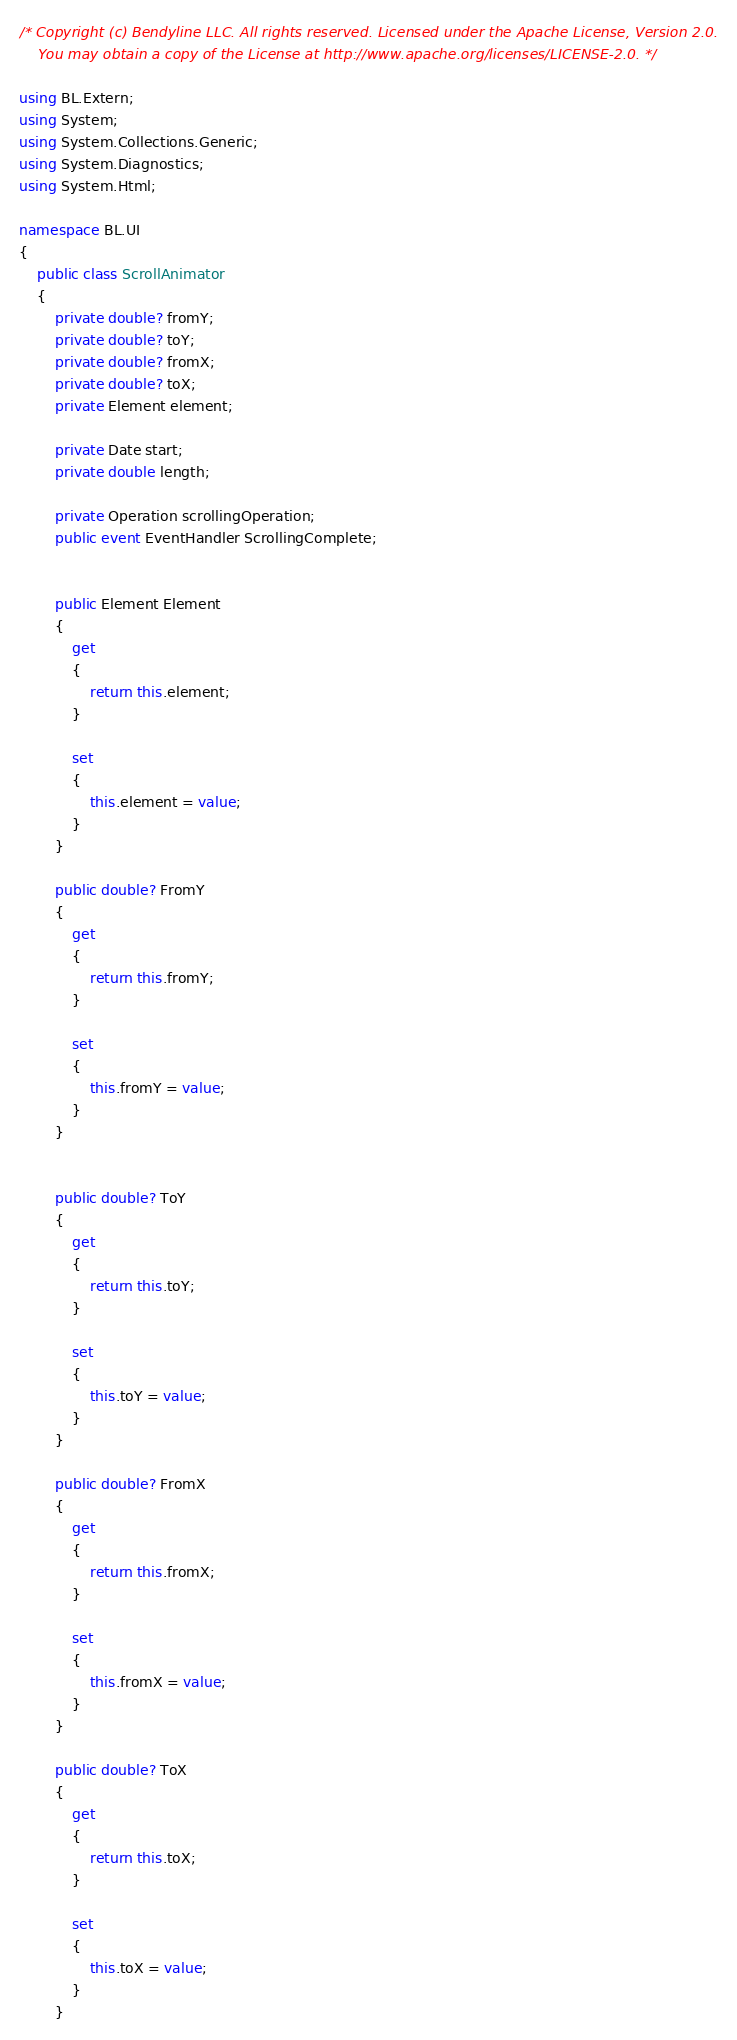<code> <loc_0><loc_0><loc_500><loc_500><_C#_>/* Copyright (c) Bendyline LLC. All rights reserved. Licensed under the Apache License, Version 2.0.
    You may obtain a copy of the License at http://www.apache.org/licenses/LICENSE-2.0. */

using BL.Extern;
using System;
using System.Collections.Generic;
using System.Diagnostics;
using System.Html;

namespace BL.UI
{
    public class ScrollAnimator
    {
        private double? fromY;
        private double? toY;
        private double? fromX;
        private double? toX;
        private Element element;

        private Date start;
        private double length;

        private Operation scrollingOperation;
        public event EventHandler ScrollingComplete;


        public Element Element
        {
            get
            {
                return this.element;
            }
            
            set
            {
                this.element = value;
            }
        }

        public double? FromY
        {
            get
            {
                return this.fromY;
            }

            set
            {
                this.fromY = value;
            }
        }


        public double? ToY
        {
            get
            {
                return this.toY;
            }

            set
            {
                this.toY = value;
            }
        }

        public double? FromX
        {
            get
            {
                return this.fromX;
            }

            set
            {
                this.fromX = value;
            }
        }

        public double? ToX
        {
            get
            {
                return this.toX;
            }

            set
            {
                this.toX = value;
            }
        }
</code> 